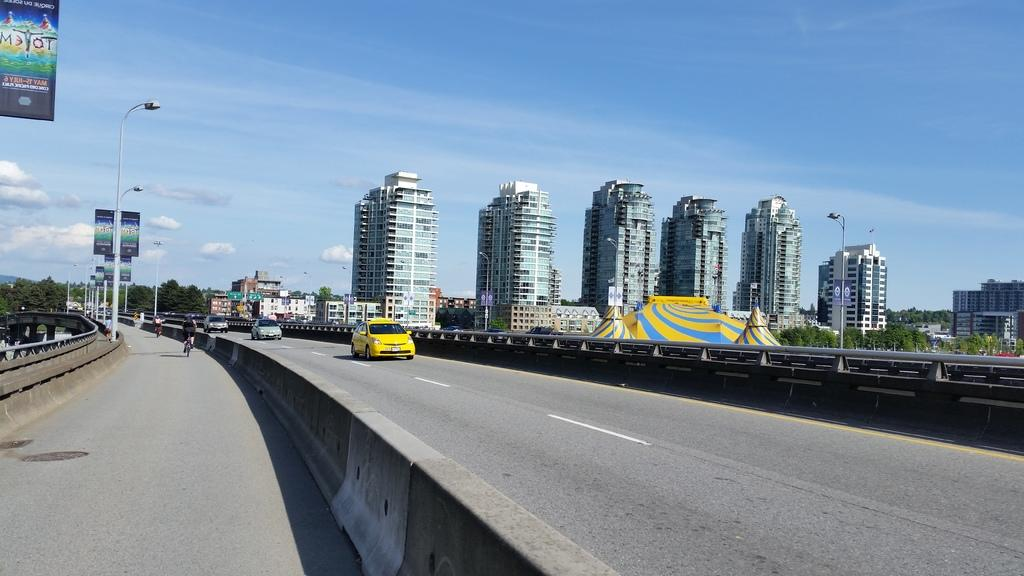What is happening on the road in the image? There are vehicles moving on the road in the image. What can be seen in the background of the image? There are trees and buildings in the background of the image. What structures are present on the side of the road in the image? There are street lights and hoardings on the side of the road in the image. How would you describe the weather in the image? The sky is cloudy in the image, suggesting a potentially overcast or rainy day. What is the price of the balls in the image? There are no balls present in the image, so it is not possible to determine the price. 